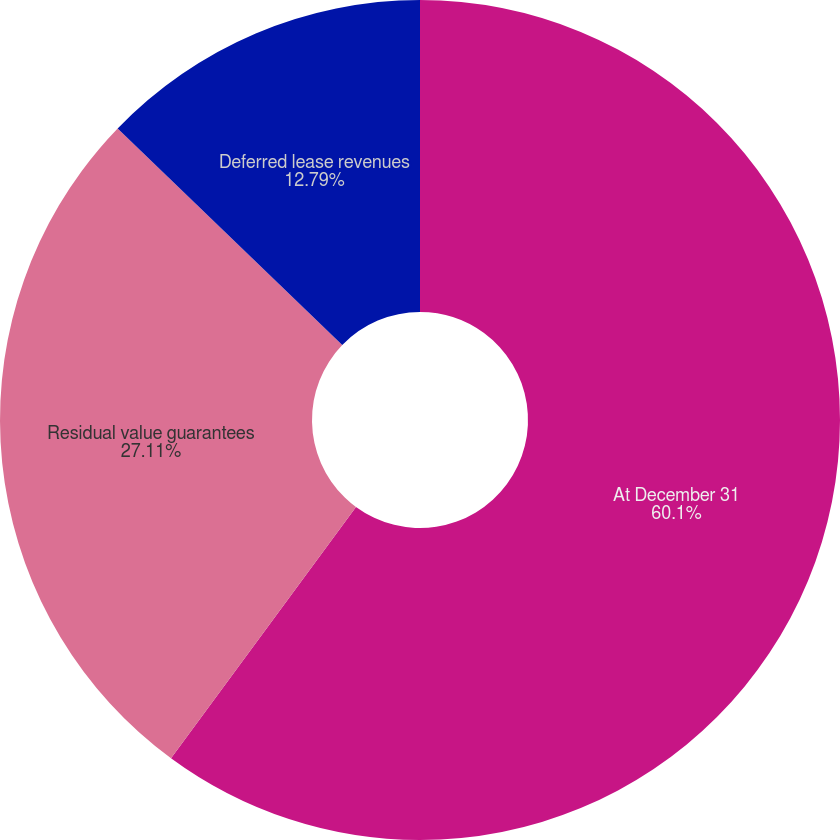<chart> <loc_0><loc_0><loc_500><loc_500><pie_chart><fcel>At December 31<fcel>Residual value guarantees<fcel>Deferred lease revenues<nl><fcel>60.1%<fcel>27.11%<fcel>12.79%<nl></chart> 